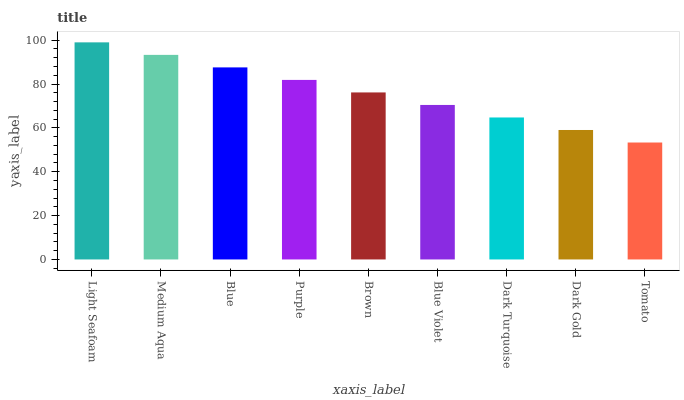Is Tomato the minimum?
Answer yes or no. Yes. Is Light Seafoam the maximum?
Answer yes or no. Yes. Is Medium Aqua the minimum?
Answer yes or no. No. Is Medium Aqua the maximum?
Answer yes or no. No. Is Light Seafoam greater than Medium Aqua?
Answer yes or no. Yes. Is Medium Aqua less than Light Seafoam?
Answer yes or no. Yes. Is Medium Aqua greater than Light Seafoam?
Answer yes or no. No. Is Light Seafoam less than Medium Aqua?
Answer yes or no. No. Is Brown the high median?
Answer yes or no. Yes. Is Brown the low median?
Answer yes or no. Yes. Is Dark Gold the high median?
Answer yes or no. No. Is Dark Gold the low median?
Answer yes or no. No. 